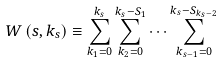Convert formula to latex. <formula><loc_0><loc_0><loc_500><loc_500>W \left ( s , k _ { s } \right ) \equiv \sum _ { k _ { 1 } = 0 } ^ { k _ { s } } \sum _ { k _ { 2 } = 0 } ^ { k _ { s } - S _ { 1 } } \cdots \sum _ { k _ { s - 1 } = 0 } ^ { k _ { s } - S _ { k _ { s } - 2 } }</formula> 